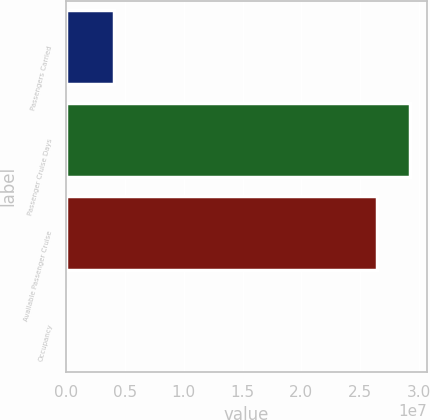<chart> <loc_0><loc_0><loc_500><loc_500><bar_chart><fcel>Passengers Carried<fcel>Passenger Cruise Days<fcel>Available Passenger Cruise<fcel>Occupancy<nl><fcel>4.01755e+06<fcel>2.92294e+07<fcel>2.64636e+07<fcel>104.5<nl></chart> 